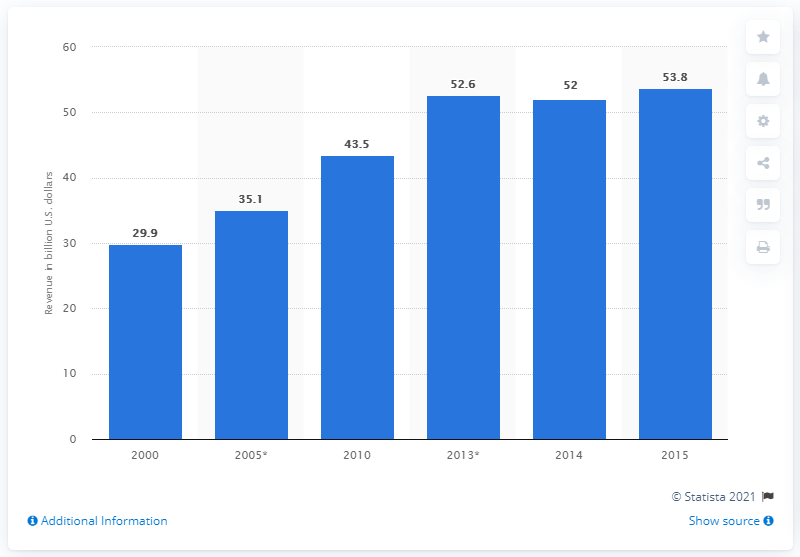List a handful of essential elements in this visual. The water utility industry generated approximately 53.8 billion dollars in revenue in 2015. 